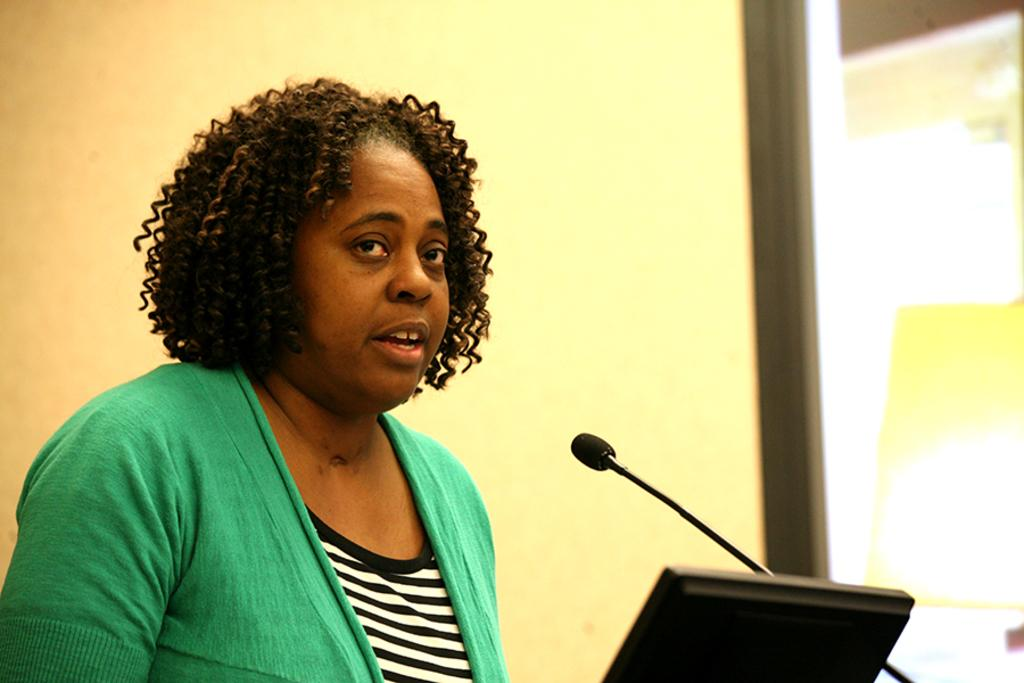Who is the main subject in the image? There is a woman in the image. What is the woman doing in the image? The woman is in front of a mic, which suggests she might be speaking or singing. What else is in front of the woman? There is a device in front of the woman, which could be a music player or a sound system. What can be seen in the background of the image? There is a wall and a glass object in the background of the image. How does the woman twist the bit in the image? There is no bit present in the image, and the woman is not shown twisting anything. 